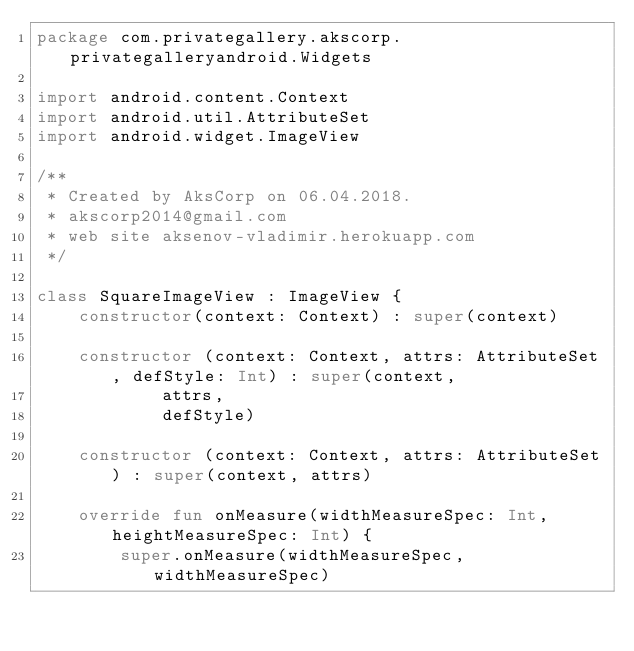<code> <loc_0><loc_0><loc_500><loc_500><_Kotlin_>package com.privategallery.akscorp.privategalleryandroid.Widgets

import android.content.Context
import android.util.AttributeSet
import android.widget.ImageView

/**
 * Created by AksCorp on 06.04.2018.
 * akscorp2014@gmail.com
 * web site aksenov-vladimir.herokuapp.com
 */

class SquareImageView : ImageView {
    constructor(context: Context) : super(context)

    constructor (context: Context, attrs: AttributeSet, defStyle: Int) : super(context,
            attrs,
            defStyle)

    constructor (context: Context, attrs: AttributeSet) : super(context, attrs)

    override fun onMeasure(widthMeasureSpec: Int, heightMeasureSpec: Int) {
        super.onMeasure(widthMeasureSpec, widthMeasureSpec)</code> 